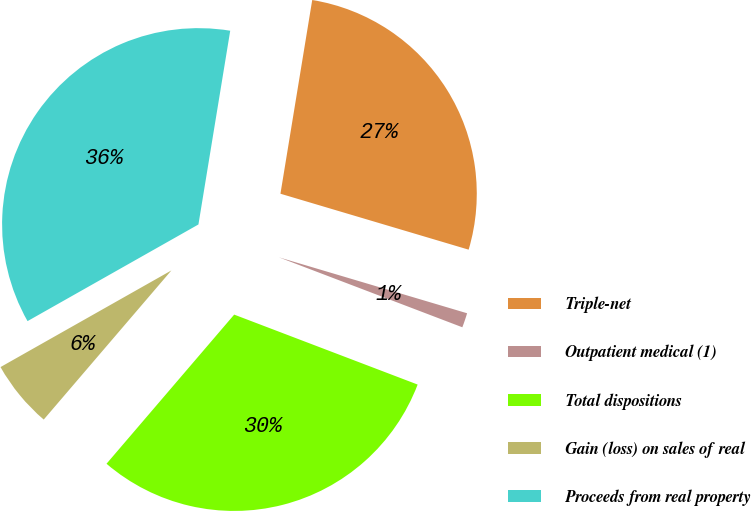<chart> <loc_0><loc_0><loc_500><loc_500><pie_chart><fcel>Triple-net<fcel>Outpatient medical (1)<fcel>Total dispositions<fcel>Gain (loss) on sales of real<fcel>Proceeds from real property<nl><fcel>27.01%<fcel>1.2%<fcel>30.47%<fcel>5.54%<fcel>35.78%<nl></chart> 